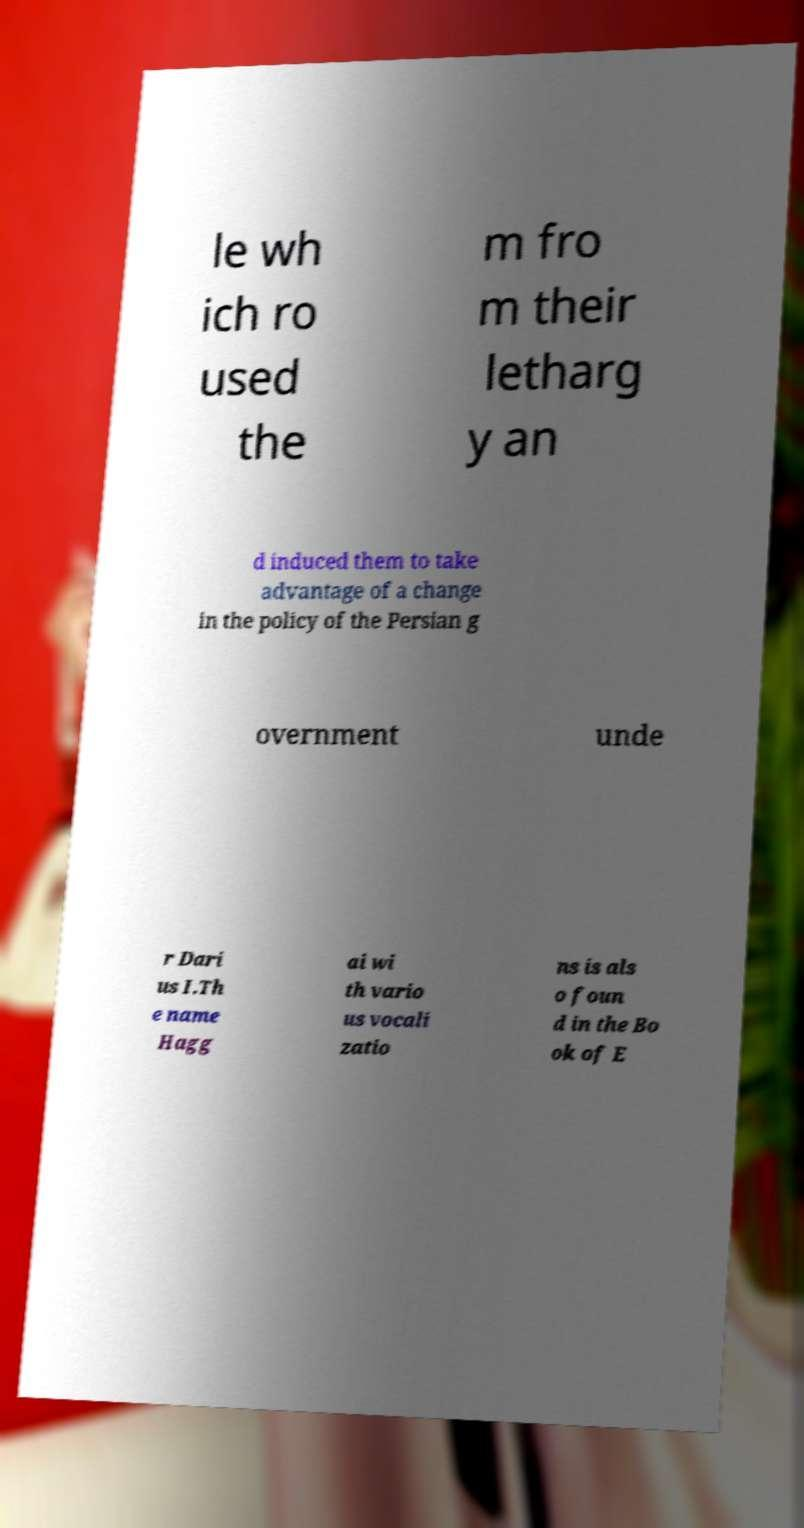Can you accurately transcribe the text from the provided image for me? le wh ich ro used the m fro m their letharg y an d induced them to take advantage of a change in the policy of the Persian g overnment unde r Dari us I.Th e name Hagg ai wi th vario us vocali zatio ns is als o foun d in the Bo ok of E 